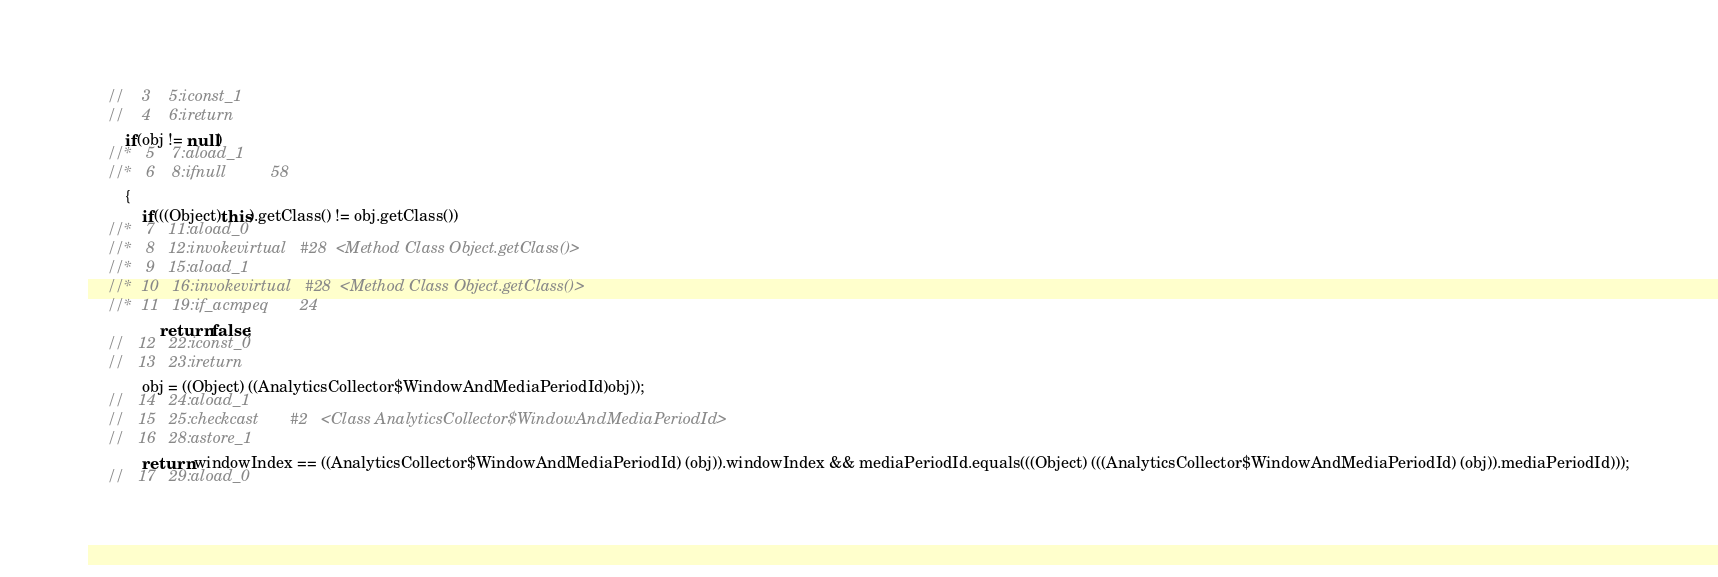<code> <loc_0><loc_0><loc_500><loc_500><_Java_>	//    3    5:iconst_1        
	//    4    6:ireturn         
		if(obj != null)
	//*   5    7:aload_1         
	//*   6    8:ifnull          58
		{
			if(((Object)this).getClass() != obj.getClass())
	//*   7   11:aload_0         
	//*   8   12:invokevirtual   #28  <Method Class Object.getClass()>
	//*   9   15:aload_1         
	//*  10   16:invokevirtual   #28  <Method Class Object.getClass()>
	//*  11   19:if_acmpeq       24
				return false;
	//   12   22:iconst_0        
	//   13   23:ireturn         
			obj = ((Object) ((AnalyticsCollector$WindowAndMediaPeriodId)obj));
	//   14   24:aload_1         
	//   15   25:checkcast       #2   <Class AnalyticsCollector$WindowAndMediaPeriodId>
	//   16   28:astore_1        
			return windowIndex == ((AnalyticsCollector$WindowAndMediaPeriodId) (obj)).windowIndex && mediaPeriodId.equals(((Object) (((AnalyticsCollector$WindowAndMediaPeriodId) (obj)).mediaPeriodId)));
	//   17   29:aload_0         </code> 